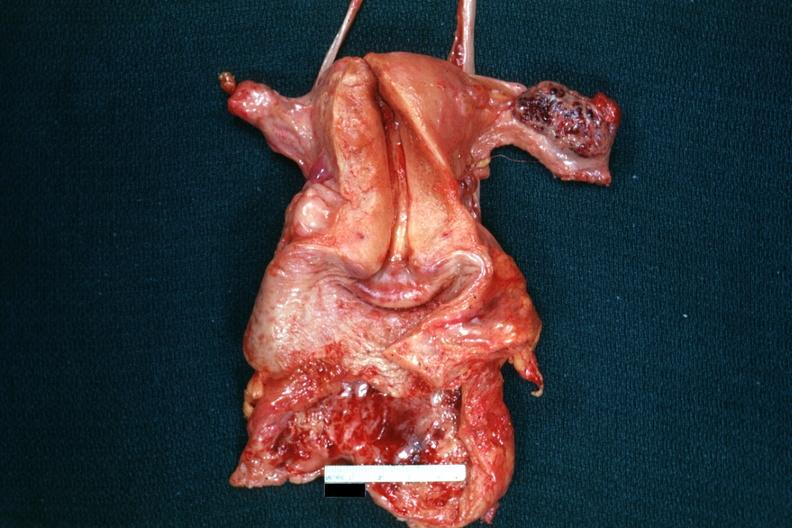what does this image show?
Answer the question using a single word or phrase. Opened uterus with adnexa and hemorrhagic mass in ovary 